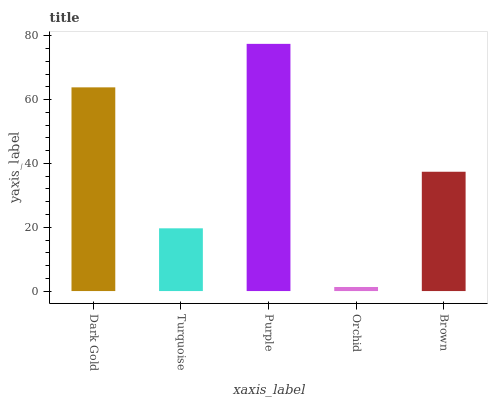Is Turquoise the minimum?
Answer yes or no. No. Is Turquoise the maximum?
Answer yes or no. No. Is Dark Gold greater than Turquoise?
Answer yes or no. Yes. Is Turquoise less than Dark Gold?
Answer yes or no. Yes. Is Turquoise greater than Dark Gold?
Answer yes or no. No. Is Dark Gold less than Turquoise?
Answer yes or no. No. Is Brown the high median?
Answer yes or no. Yes. Is Brown the low median?
Answer yes or no. Yes. Is Turquoise the high median?
Answer yes or no. No. Is Dark Gold the low median?
Answer yes or no. No. 